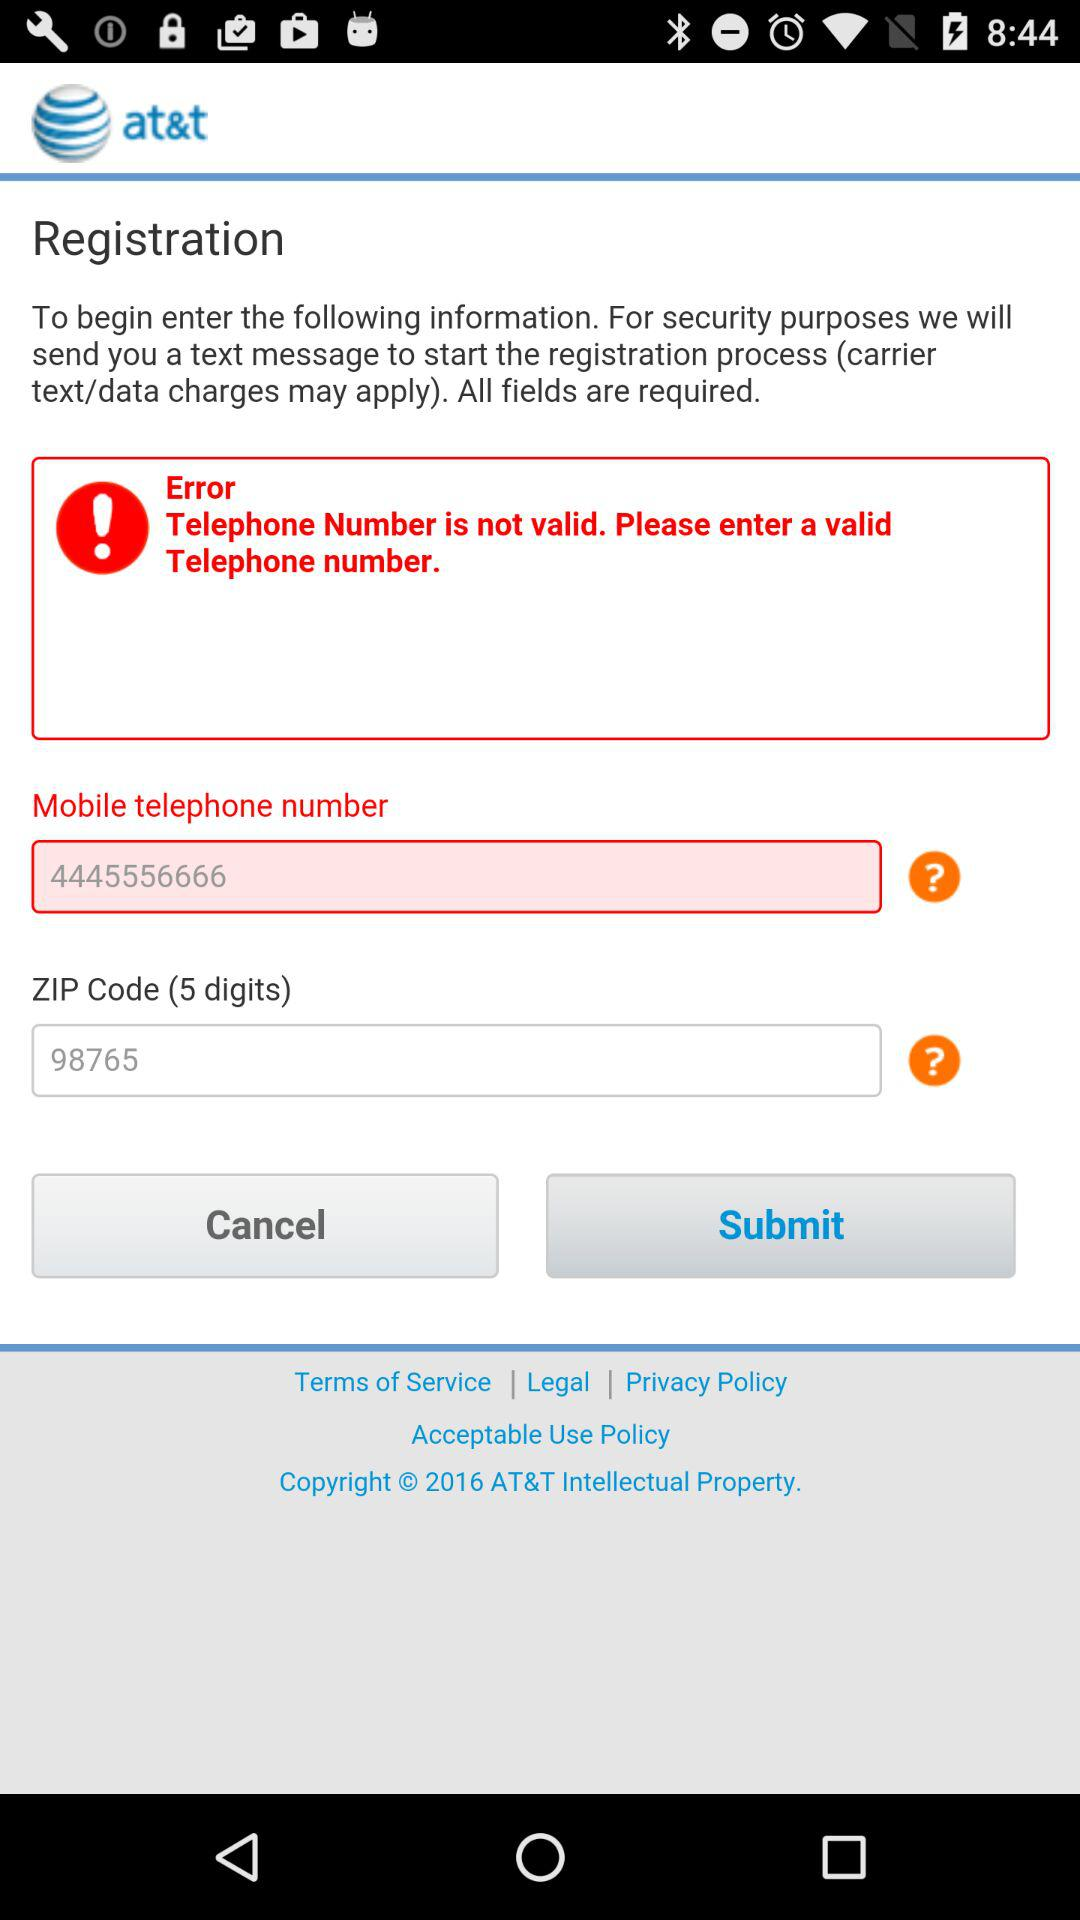What is the ZIP code? The ZIP code is 98765. 